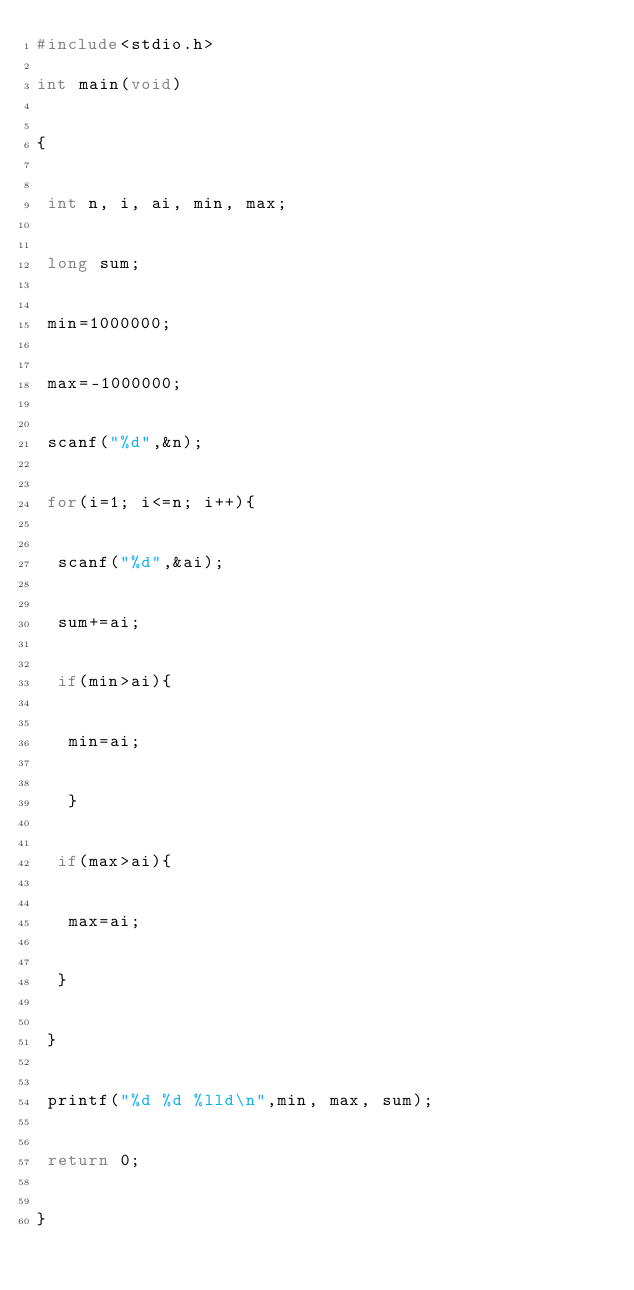Convert code to text. <code><loc_0><loc_0><loc_500><loc_500><_C_>#include<stdio.h>

int main(void)


{


 int n, i, ai, min, max;


 long sum;


 min=1000000;


 max=-1000000;


 scanf("%d",&n);


 for(i=1; i<=n; i++){


  scanf("%d",&ai);


  sum+=ai;


  if(min>ai){


   min=ai;


   }


  if(max>ai){


   max=ai;


  }


 }


 printf("%d %d %lld\n",min, max, sum);


 return 0;


}</code> 